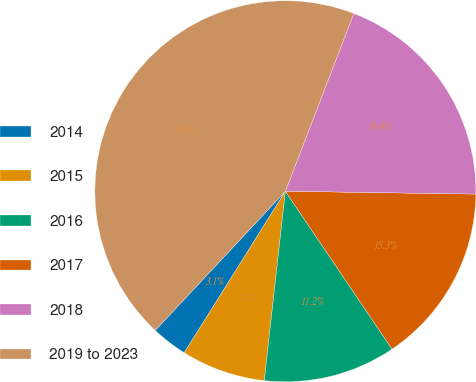Convert chart to OTSL. <chart><loc_0><loc_0><loc_500><loc_500><pie_chart><fcel>2014<fcel>2015<fcel>2016<fcel>2017<fcel>2018<fcel>2019 to 2023<nl><fcel>3.06%<fcel>7.14%<fcel>11.22%<fcel>15.31%<fcel>19.39%<fcel>43.88%<nl></chart> 